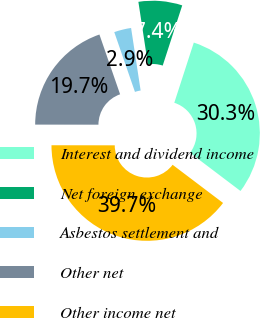<chart> <loc_0><loc_0><loc_500><loc_500><pie_chart><fcel>Interest and dividend income<fcel>Net foreign exchange<fcel>Asbestos settlement and<fcel>Other net<fcel>Other income net<nl><fcel>30.32%<fcel>7.4%<fcel>2.89%<fcel>19.68%<fcel>39.71%<nl></chart> 